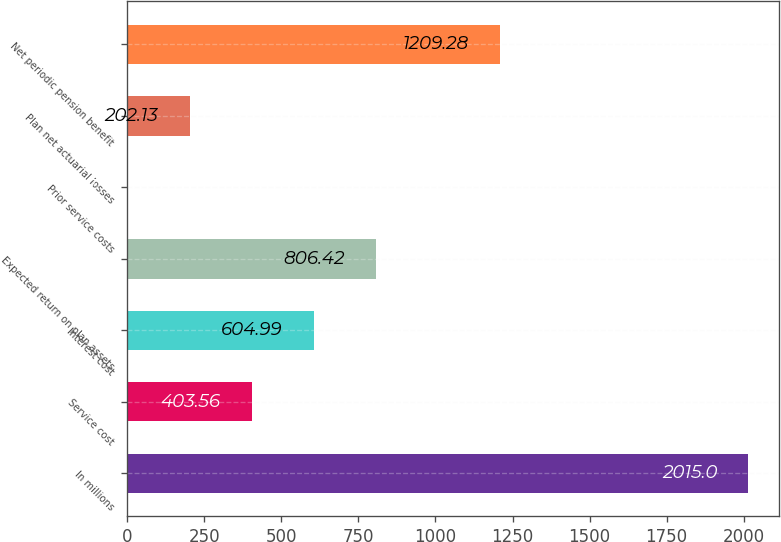<chart> <loc_0><loc_0><loc_500><loc_500><bar_chart><fcel>In millions<fcel>Service cost<fcel>Interest cost<fcel>Expected return on plan assets<fcel>Prior service costs<fcel>Plan net actuarial losses<fcel>Net periodic pension benefit<nl><fcel>2015<fcel>403.56<fcel>604.99<fcel>806.42<fcel>0.7<fcel>202.13<fcel>1209.28<nl></chart> 